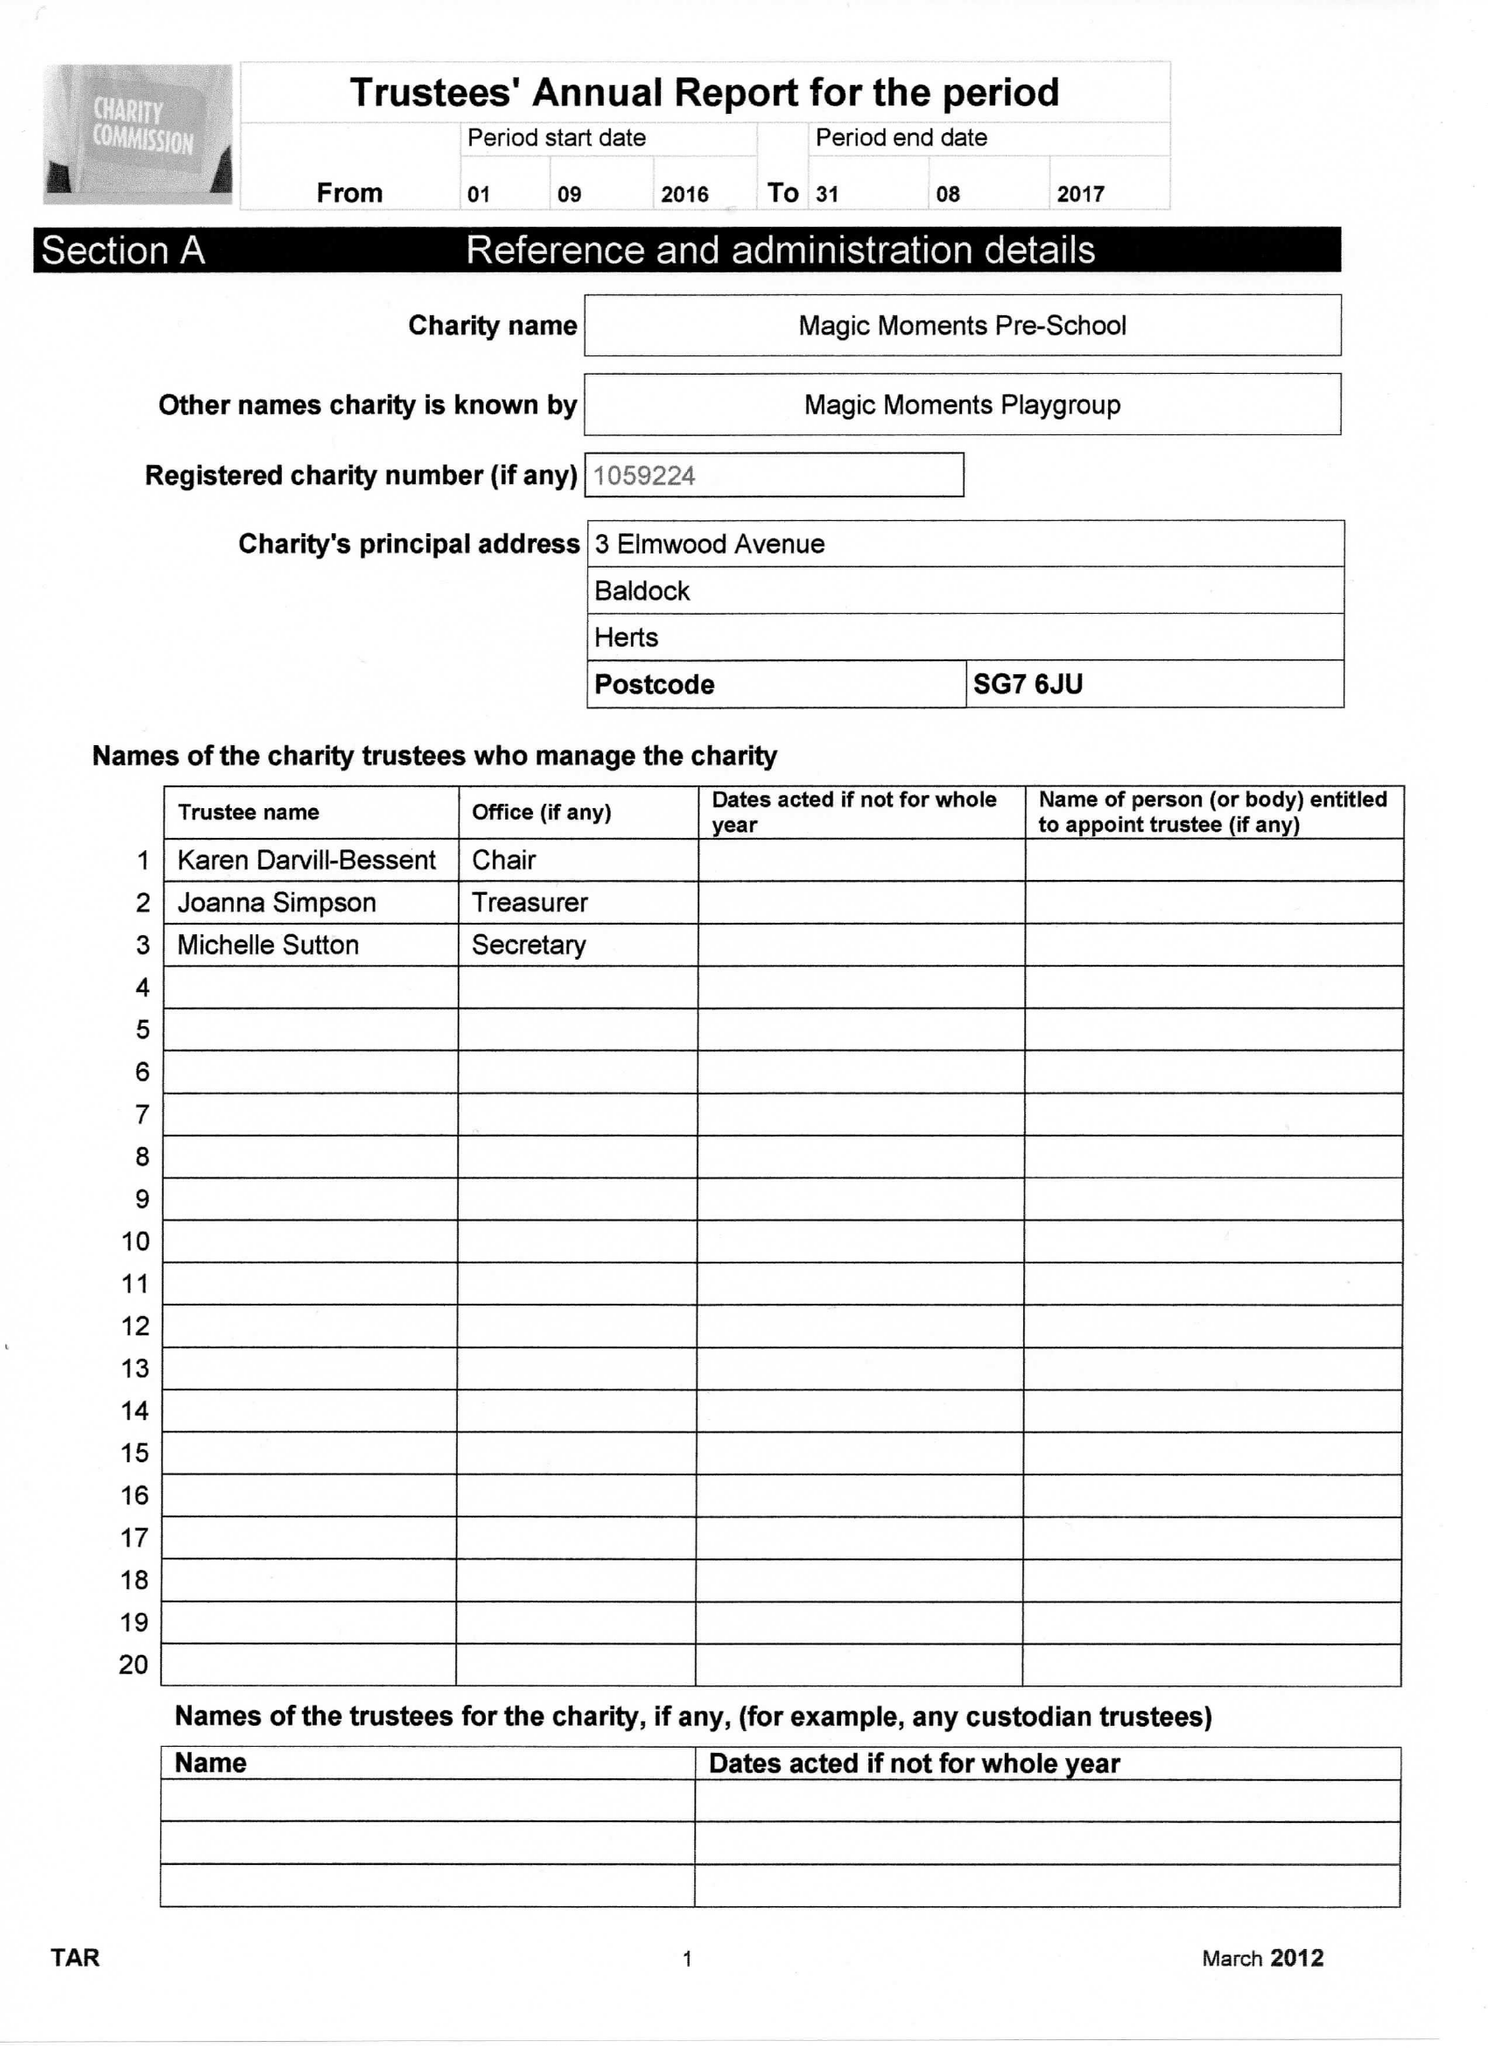What is the value for the address__street_line?
Answer the question using a single word or phrase. 3 ELMWOOD AVENUE 